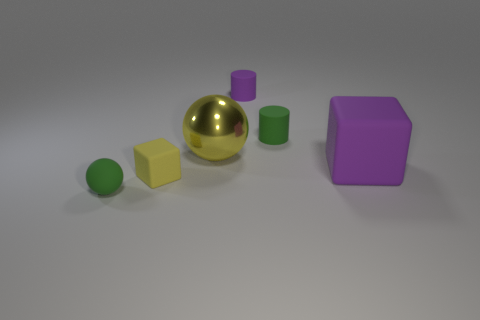Add 1 green matte cylinders. How many objects exist? 7 Subtract all balls. How many objects are left? 4 Subtract 0 red cubes. How many objects are left? 6 Subtract all small green rubber objects. Subtract all purple things. How many objects are left? 2 Add 4 large metallic spheres. How many large metallic spheres are left? 5 Add 1 cyan metallic balls. How many cyan metallic balls exist? 1 